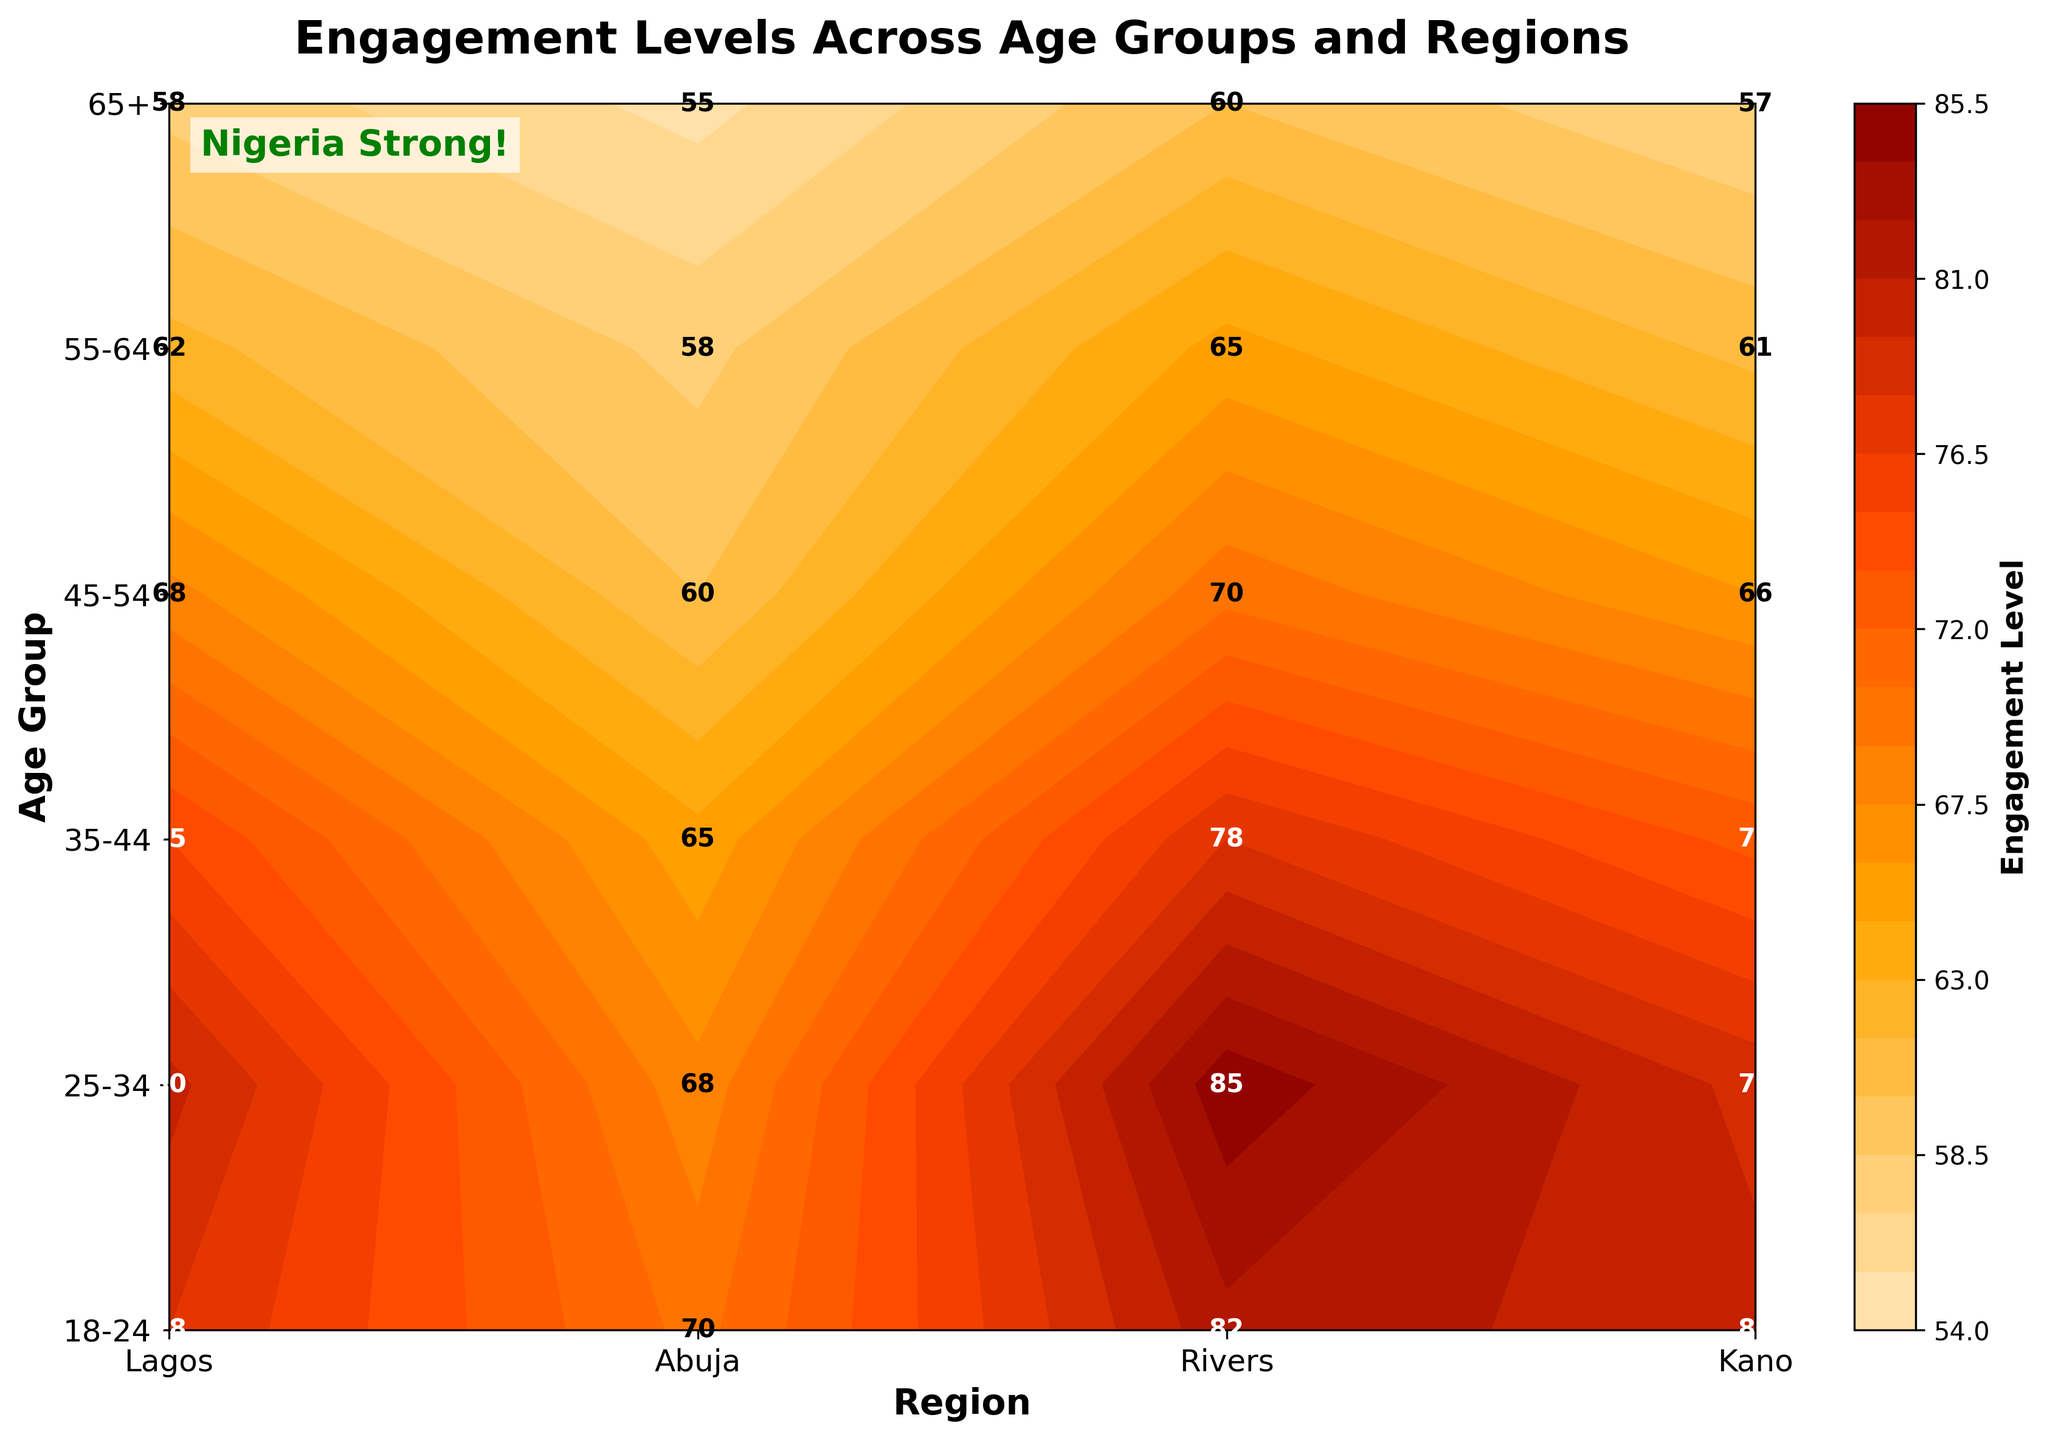What is the title of the contour plot? The title is located at the top of the plot. It reads "Engagement Levels Across Age Groups and Regions."
Answer: Engagement Levels Across Age Groups and Regions Which region shows the highest engagement level for the 25-34 age group? By looking at the intersection of the "25-34" age group and "Region" axis, Lagos has the highest engagement level with a value of 85.
Answer: Lagos How does the engagement level in Rivers differ between the 18-24 age group and the 55-64 age group? The value for the 18-24 age group in Rivers is 80, and for the 55-64 age group, it is 61. The difference can be calculated as 80 - 61.
Answer: 19 What is the average engagement level in Abuja across all age groups? Summing up the engagement levels for Abuja: 78, 80, 75, 68, 62, and 58, we get 421. Dividing by the number of age groups (6), we get 421/6.
Answer: 70.2 Which age group in Kano has the least engagement level? By examining the values for Kano, the age group 65+ has the least engagement level with a value of 55.
Answer: 65+ Compare the engagement levels between Lagos and Kano for the 35-44 age group. For the 35-44 age group, Lagos has an engagement level of 78, and Kano has 65. So, Lagos has a higher engagement level than Kano.
Answer: Lagos What is the engagement level in Lagos for the 45-54 age group and how does it compare to the engagement level for the 18-24 age group in the same region? The engagement level for 45-54 in Lagos is 70. For 18-24, it is 82. Therefore, the 18-24 age group has a higher engagement level than the 45-54 group.
Answer: 82 > 70 Which age group shows the highest engagement level overall and in which region? By examining all values, the highest engagement level is for the 25-34 age group in Lagos with a value of 85.
Answer: 25-34 in Lagos 